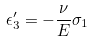Convert formula to latex. <formula><loc_0><loc_0><loc_500><loc_500>\epsilon _ { 3 } ^ { \prime } = - \frac { \nu } { E } \sigma _ { 1 }</formula> 